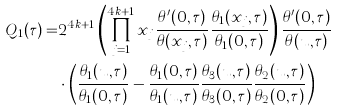<formula> <loc_0><loc_0><loc_500><loc_500>Q _ { 1 } ( \tau ) = & 2 ^ { 4 k + 1 } \left ( \prod _ { j = 1 } ^ { 4 k + 1 } x _ { j } \frac { \theta ^ { \prime } ( 0 , \tau ) } { \theta ( x _ { j } , \tau ) } \frac { \theta _ { 1 } ( x _ { j } , \tau ) } { \theta _ { 1 } ( 0 , \tau ) } \right ) \frac { \theta ^ { \prime } ( 0 , \tau ) } { \theta ( u , \tau ) } \\ & \cdot \left ( \frac { \theta _ { 1 } ( u , \tau ) } { \theta _ { 1 } ( 0 , \tau ) } - \frac { \theta _ { 1 } ( 0 , \tau ) } { \theta _ { 1 } ( u , \tau ) } \frac { \theta _ { 3 } ( u , \tau ) } { \theta _ { 3 } ( 0 , \tau ) } \frac { \theta _ { 2 } ( u , \tau ) } { \theta _ { 2 } ( 0 , \tau ) } \right )</formula> 